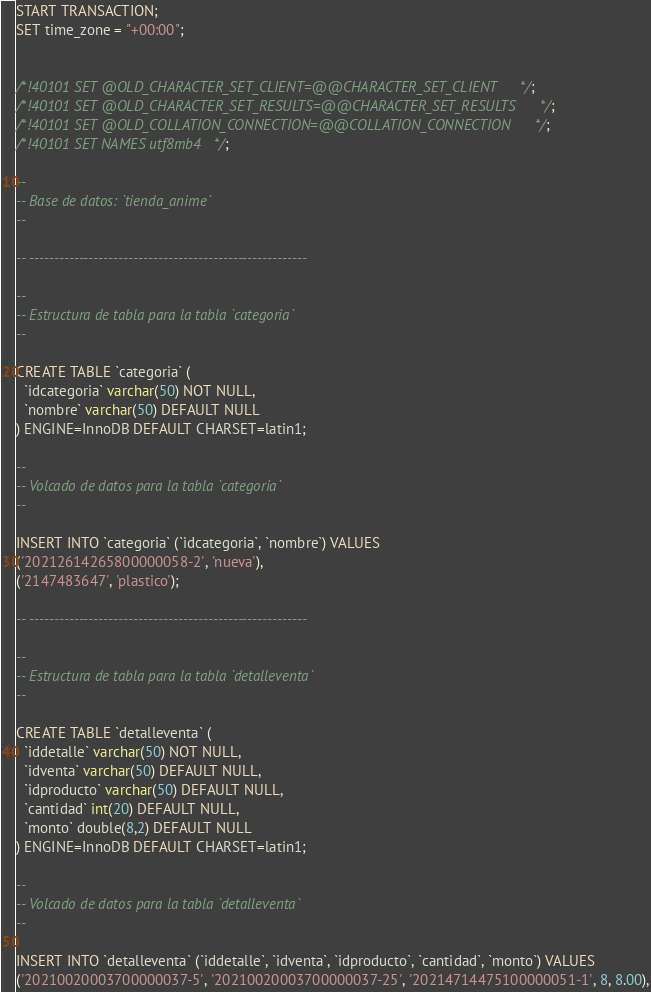Convert code to text. <code><loc_0><loc_0><loc_500><loc_500><_SQL_>START TRANSACTION;
SET time_zone = "+00:00";


/*!40101 SET @OLD_CHARACTER_SET_CLIENT=@@CHARACTER_SET_CLIENT */;
/*!40101 SET @OLD_CHARACTER_SET_RESULTS=@@CHARACTER_SET_RESULTS */;
/*!40101 SET @OLD_COLLATION_CONNECTION=@@COLLATION_CONNECTION */;
/*!40101 SET NAMES utf8mb4 */;

--
-- Base de datos: `tienda_anime`
--

-- --------------------------------------------------------

--
-- Estructura de tabla para la tabla `categoria`
--

CREATE TABLE `categoria` (
  `idcategoria` varchar(50) NOT NULL,
  `nombre` varchar(50) DEFAULT NULL
) ENGINE=InnoDB DEFAULT CHARSET=latin1;

--
-- Volcado de datos para la tabla `categoria`
--

INSERT INTO `categoria` (`idcategoria`, `nombre`) VALUES
('20212614265800000058-2', 'nueva'),
('2147483647', 'plastico');

-- --------------------------------------------------------

--
-- Estructura de tabla para la tabla `detalleventa`
--

CREATE TABLE `detalleventa` (
  `iddetalle` varchar(50) NOT NULL,
  `idventa` varchar(50) DEFAULT NULL,
  `idproducto` varchar(50) DEFAULT NULL,
  `cantidad` int(20) DEFAULT NULL,
  `monto` double(8,2) DEFAULT NULL
) ENGINE=InnoDB DEFAULT CHARSET=latin1;

--
-- Volcado de datos para la tabla `detalleventa`
--

INSERT INTO `detalleventa` (`iddetalle`, `idventa`, `idproducto`, `cantidad`, `monto`) VALUES
('20210020003700000037-5', '20210020003700000037-25', '20214714475100000051-1', 8, 8.00),</code> 